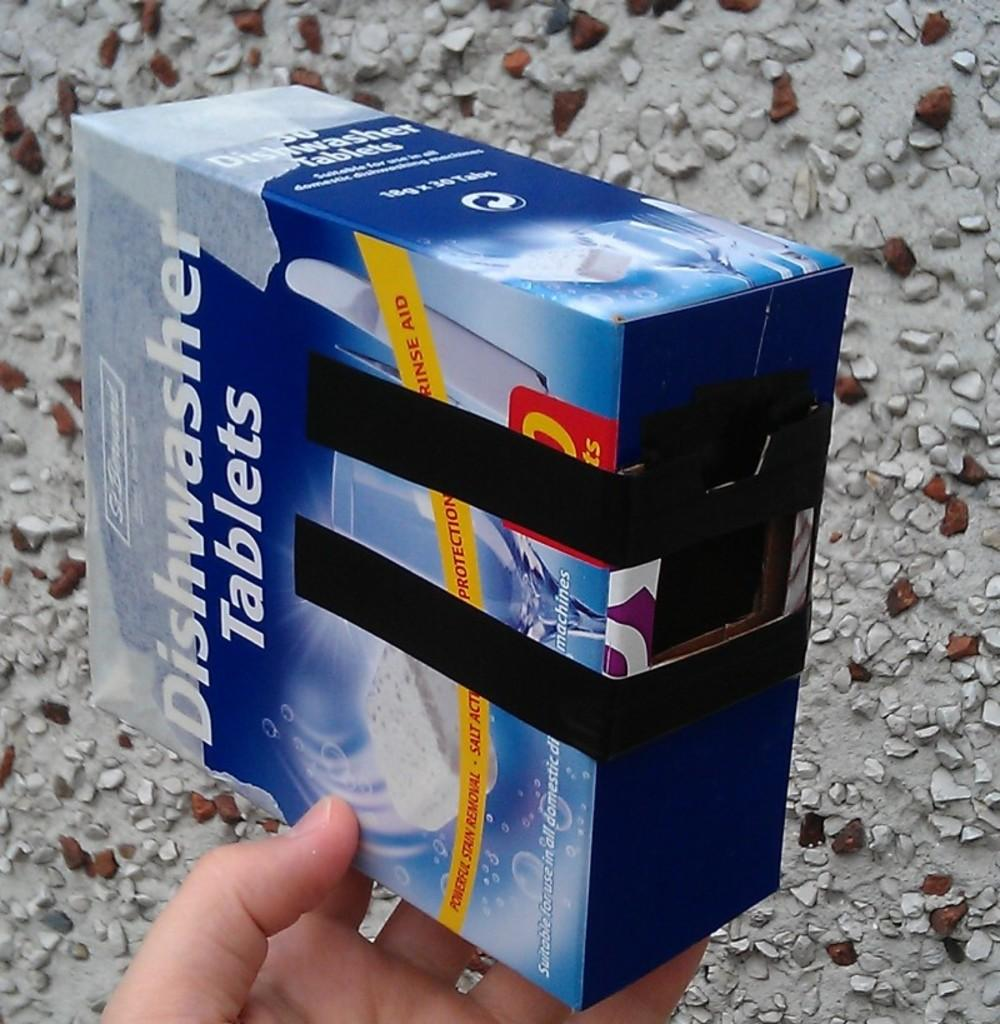<image>
Present a compact description of the photo's key features. a box that is labeled 'dishwasher tablets' on the front 